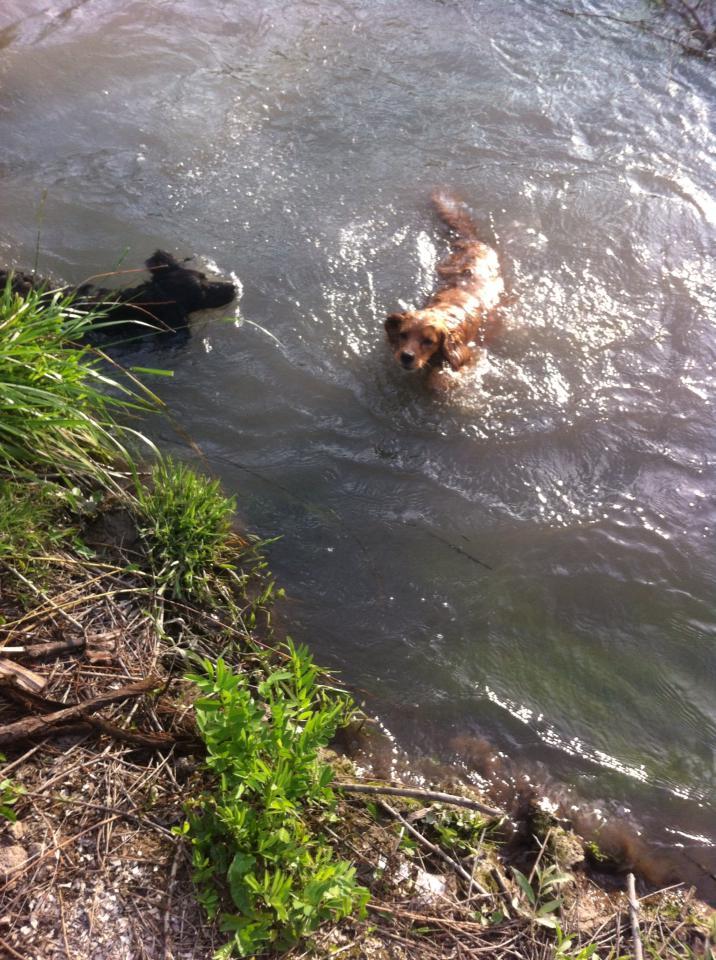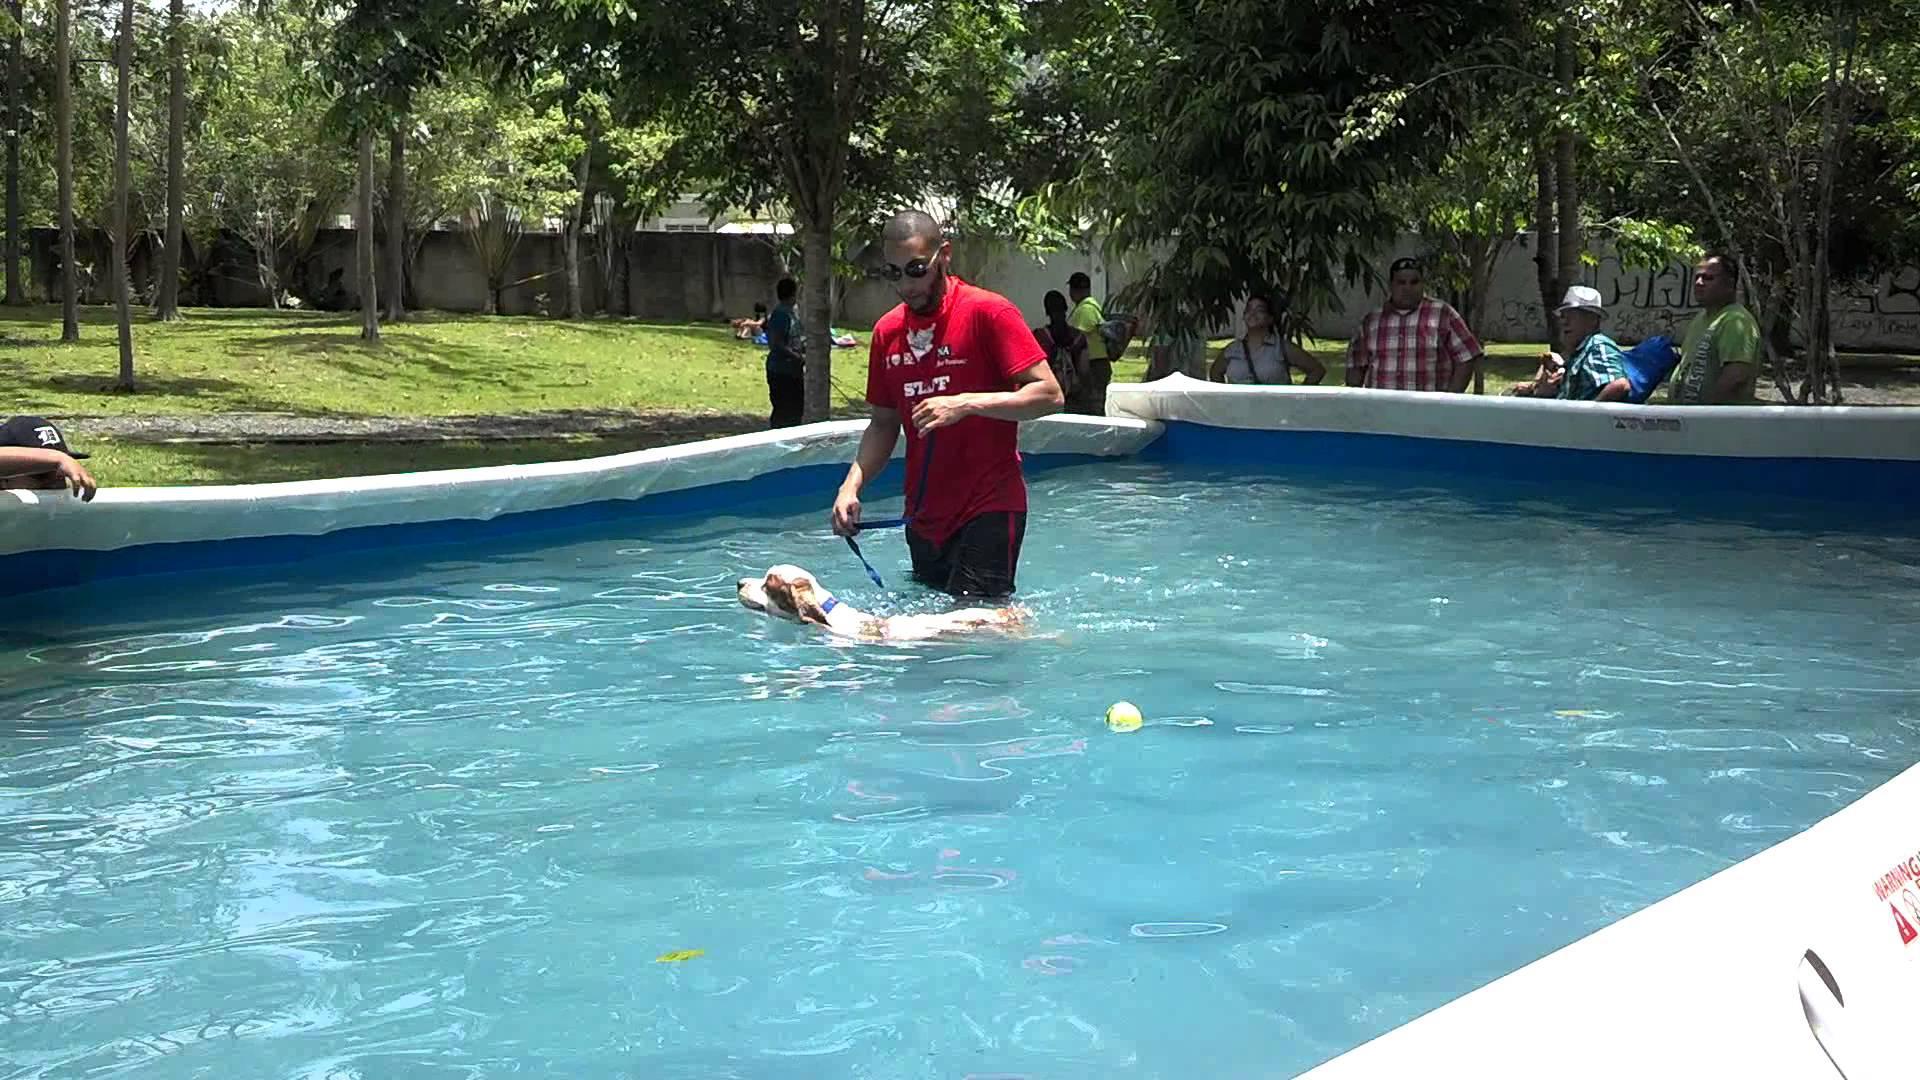The first image is the image on the left, the second image is the image on the right. For the images shown, is this caption "In one of the images, there is a dog swimming while carrying an object in its mouth." true? Answer yes or no. No. 